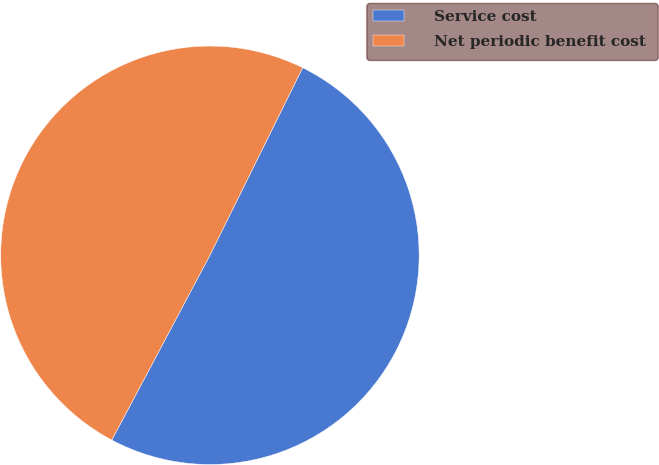Convert chart. <chart><loc_0><loc_0><loc_500><loc_500><pie_chart><fcel>Service cost<fcel>Net periodic benefit cost<nl><fcel>50.46%<fcel>49.54%<nl></chart> 